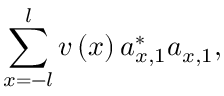<formula> <loc_0><loc_0><loc_500><loc_500>\sum _ { x = - l } ^ { l } v \left ( x \right ) a _ { x , 1 } ^ { \ast } a _ { x , 1 } ,</formula> 